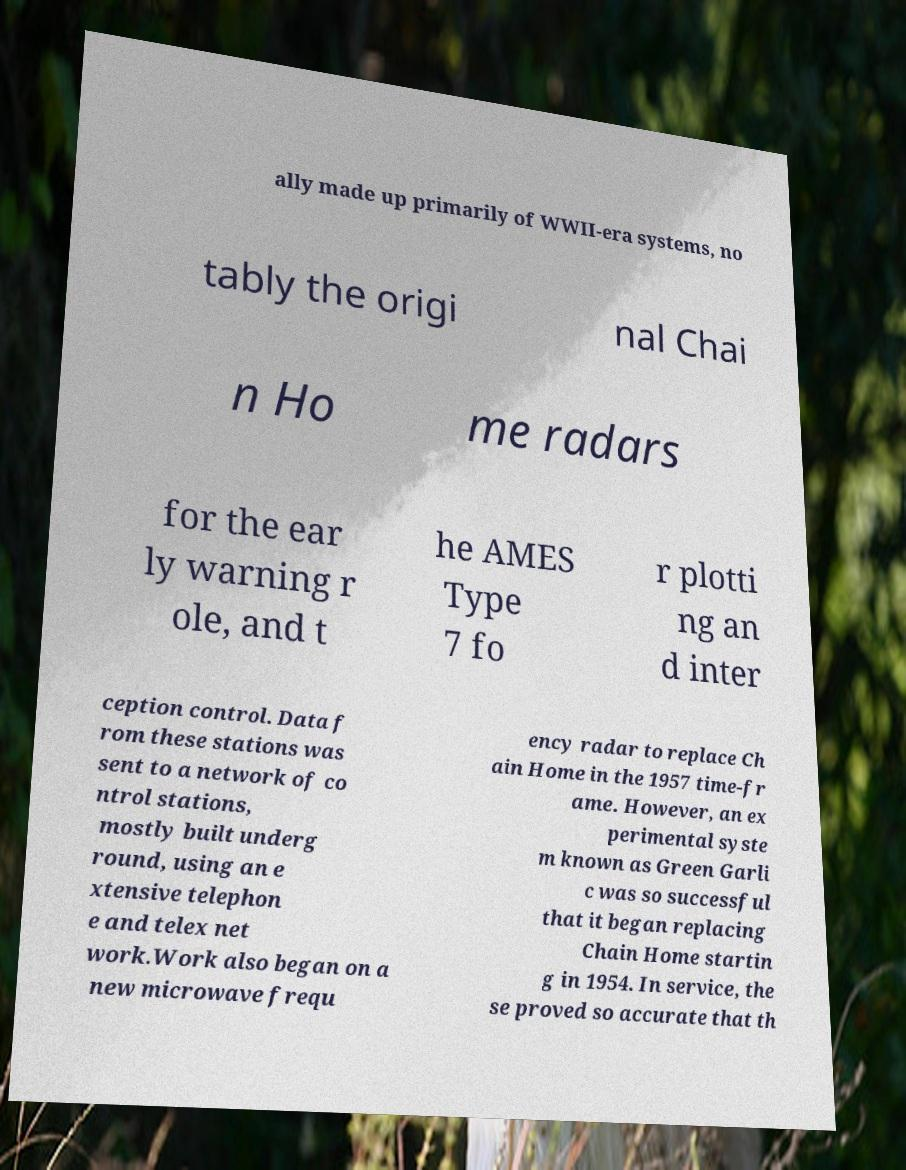Can you accurately transcribe the text from the provided image for me? ally made up primarily of WWII-era systems, no tably the origi nal Chai n Ho me radars for the ear ly warning r ole, and t he AMES Type 7 fo r plotti ng an d inter ception control. Data f rom these stations was sent to a network of co ntrol stations, mostly built underg round, using an e xtensive telephon e and telex net work.Work also began on a new microwave frequ ency radar to replace Ch ain Home in the 1957 time-fr ame. However, an ex perimental syste m known as Green Garli c was so successful that it began replacing Chain Home startin g in 1954. In service, the se proved so accurate that th 